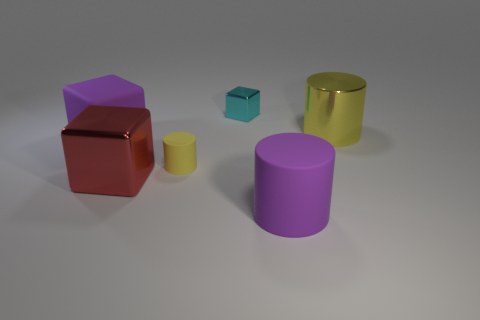Add 3 gray matte cubes. How many objects exist? 9 Add 6 red shiny objects. How many red shiny objects are left? 7 Add 5 large metal cylinders. How many large metal cylinders exist? 6 Subtract 0 green blocks. How many objects are left? 6 Subtract all red metal cubes. Subtract all matte cubes. How many objects are left? 4 